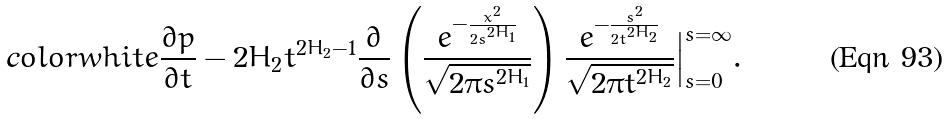Convert formula to latex. <formula><loc_0><loc_0><loc_500><loc_500>\text  color{white} { \frac { \partial p } { \partial t } } - 2 H _ { 2 } t ^ { 2 H _ { 2 } - 1 } \frac { \partial } { \partial s } \left ( \frac { e ^ { - \frac { x ^ { 2 } } { 2 s ^ { 2 H _ { 1 } } } } } { \sqrt { 2 \pi s ^ { 2 H _ { 1 } } } } \right ) \frac { e ^ { - \frac { s ^ { 2 } } { 2 t ^ { 2 H _ { 2 } } } } } { \sqrt { 2 \pi t ^ { 2 H _ { 2 } } } } \Big | _ { s = 0 } ^ { s = \infty } .</formula> 